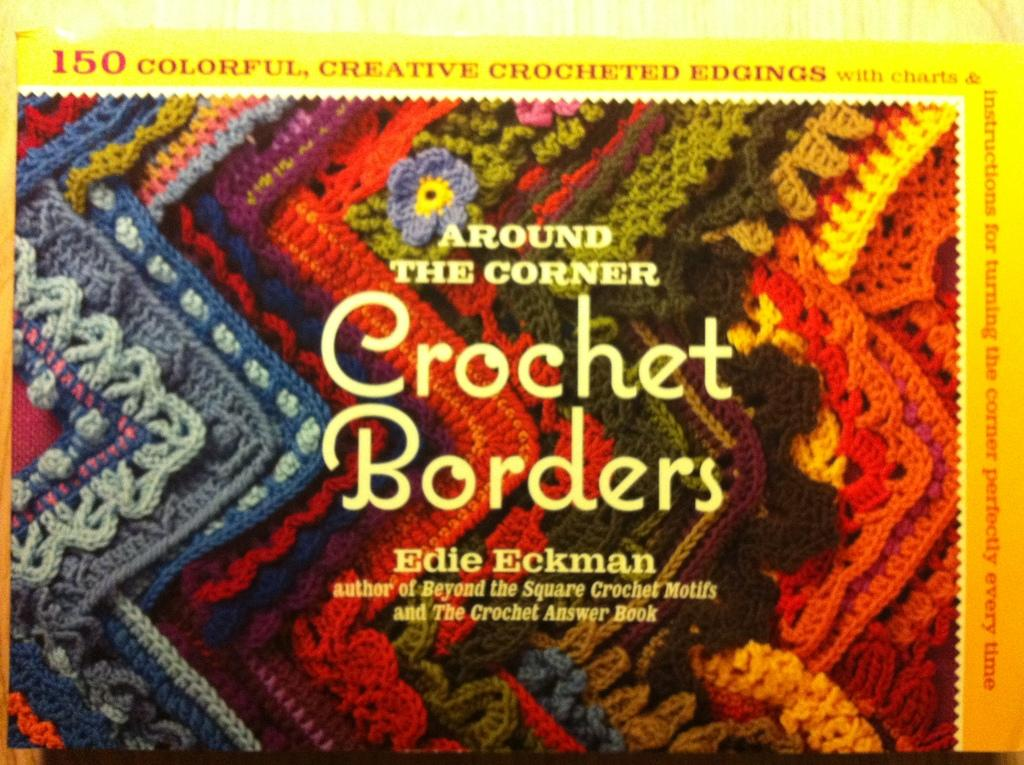<image>
Summarize the visual content of the image. Packaging advertises crochet borders with 150 colorful and creative crocheted edgings. 